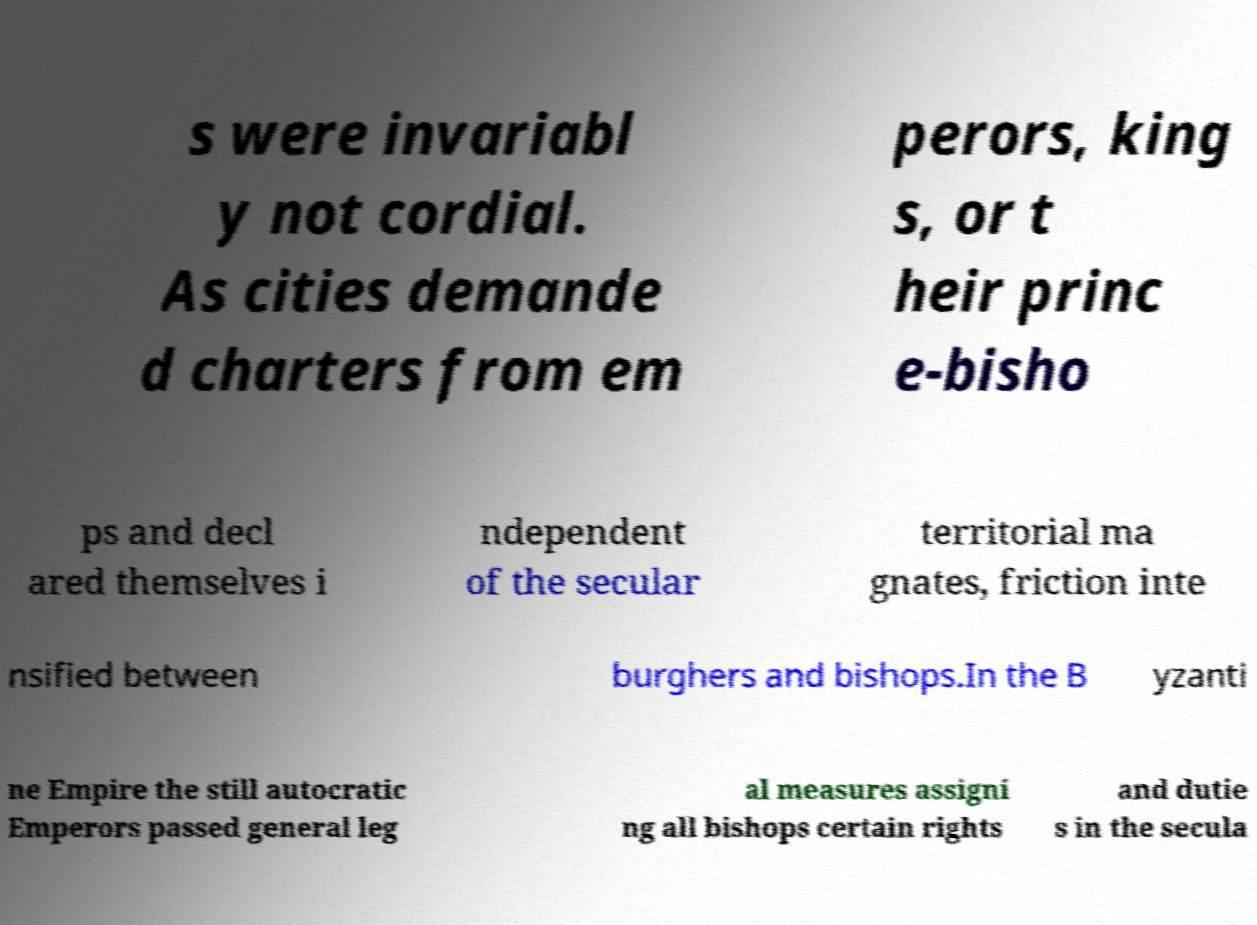Could you assist in decoding the text presented in this image and type it out clearly? s were invariabl y not cordial. As cities demande d charters from em perors, king s, or t heir princ e-bisho ps and decl ared themselves i ndependent of the secular territorial ma gnates, friction inte nsified between burghers and bishops.In the B yzanti ne Empire the still autocratic Emperors passed general leg al measures assigni ng all bishops certain rights and dutie s in the secula 